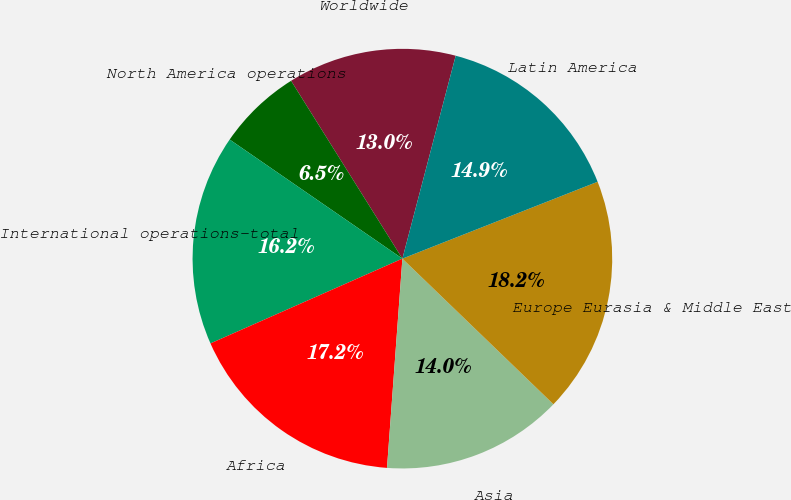<chart> <loc_0><loc_0><loc_500><loc_500><pie_chart><fcel>Worldwide<fcel>North America operations<fcel>International operations-total<fcel>Africa<fcel>Asia<fcel>Europe Eurasia & Middle East<fcel>Latin America<nl><fcel>12.99%<fcel>6.49%<fcel>16.23%<fcel>17.21%<fcel>13.96%<fcel>18.18%<fcel>14.94%<nl></chart> 